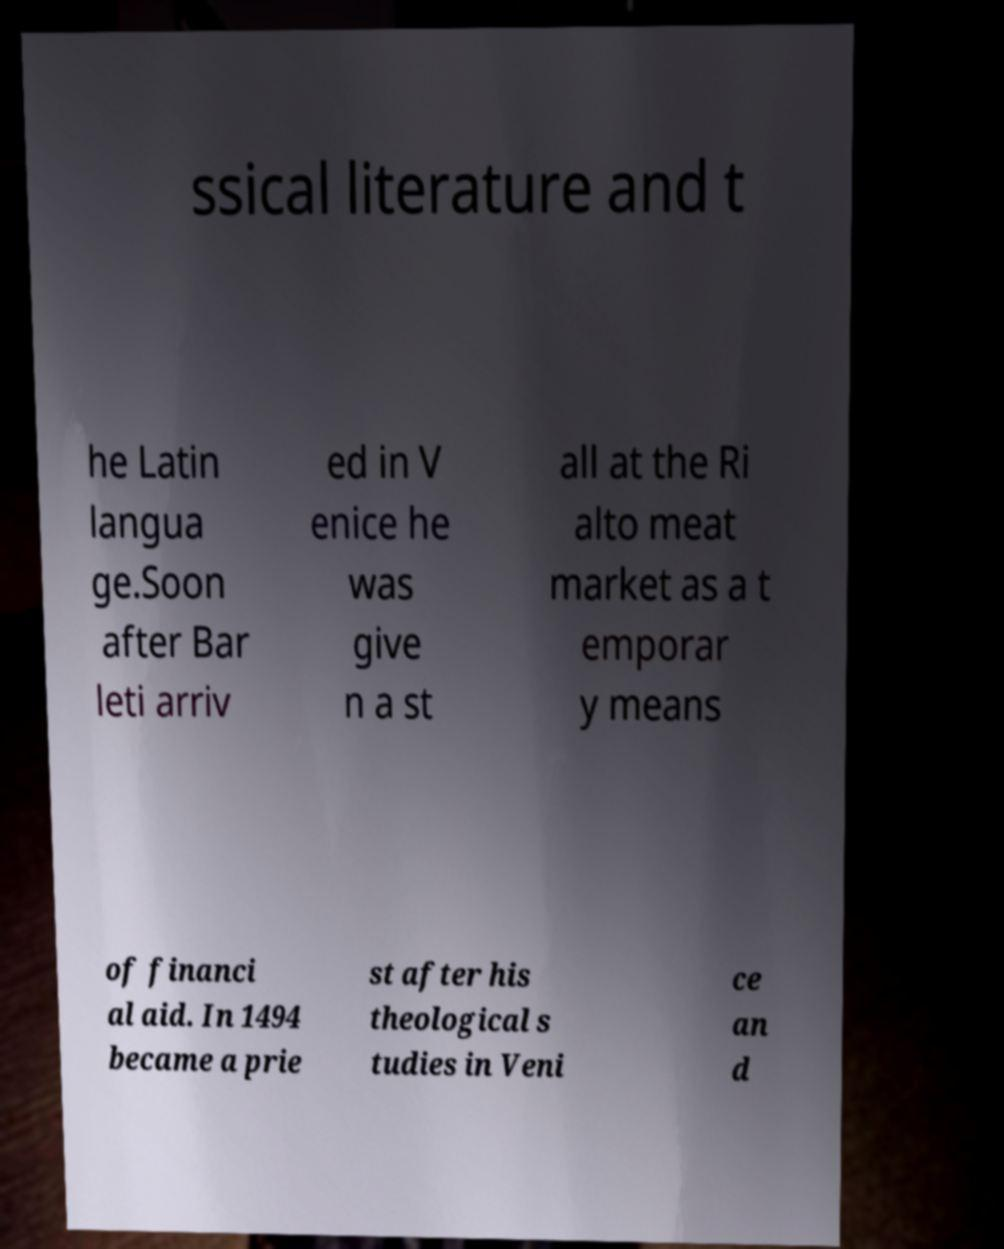I need the written content from this picture converted into text. Can you do that? ssical literature and t he Latin langua ge.Soon after Bar leti arriv ed in V enice he was give n a st all at the Ri alto meat market as a t emporar y means of financi al aid. In 1494 became a prie st after his theological s tudies in Veni ce an d 